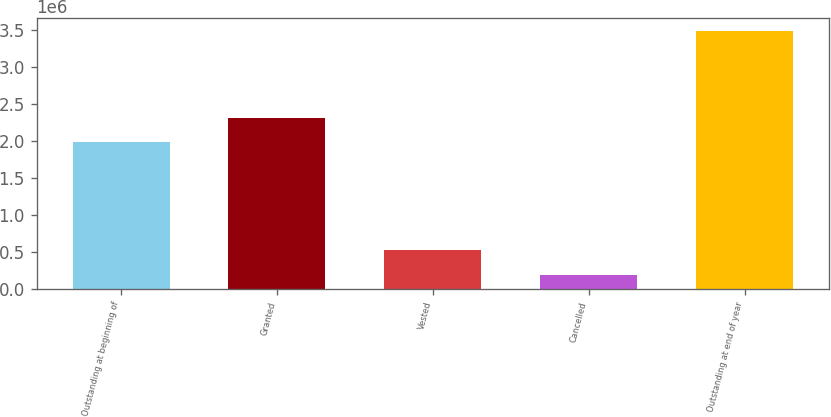<chart> <loc_0><loc_0><loc_500><loc_500><bar_chart><fcel>Outstanding at beginning of<fcel>Granted<fcel>Vested<fcel>Cancelled<fcel>Outstanding at end of year<nl><fcel>1.97826e+06<fcel>2.30669e+06<fcel>522362<fcel>193932<fcel>3.47823e+06<nl></chart> 